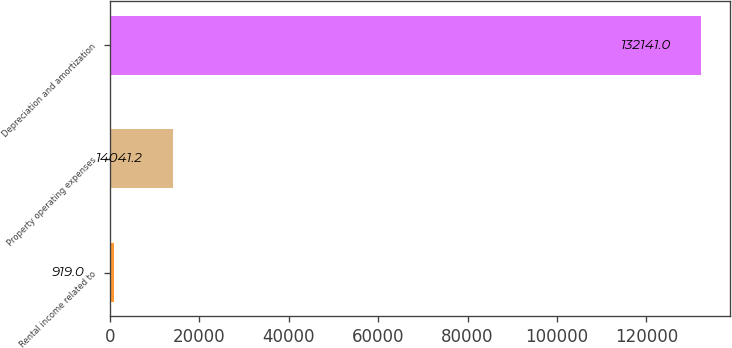Convert chart. <chart><loc_0><loc_0><loc_500><loc_500><bar_chart><fcel>Rental income related to<fcel>Property operating expenses<fcel>Depreciation and amortization<nl><fcel>919<fcel>14041.2<fcel>132141<nl></chart> 